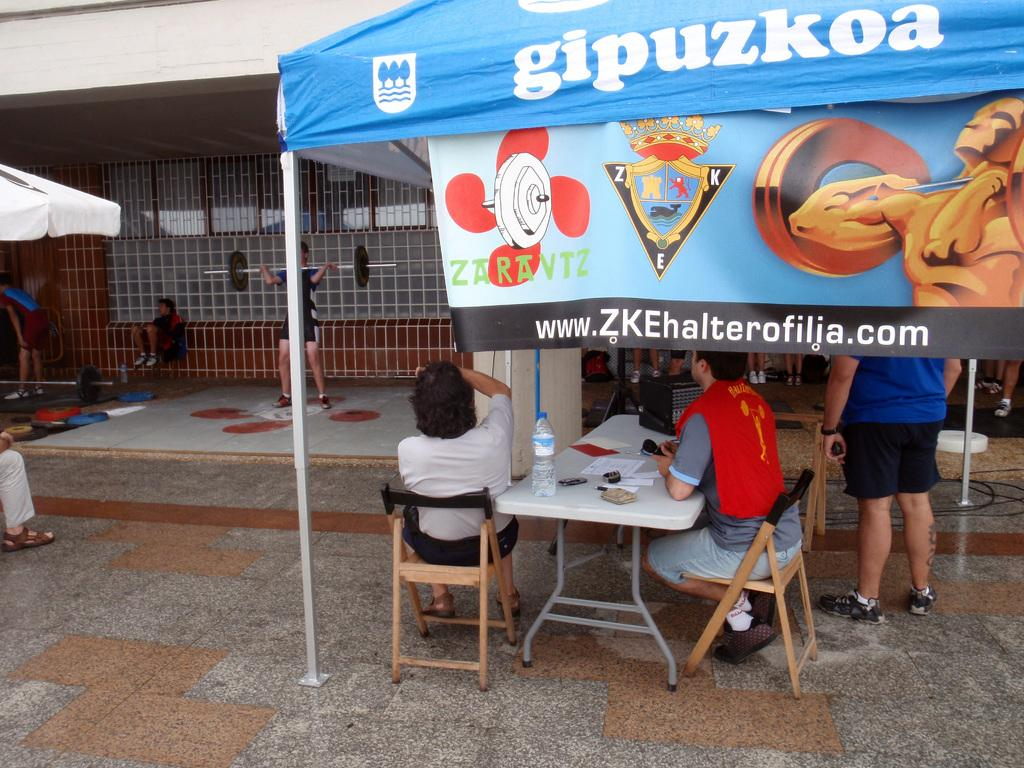What are the people doing under the tent in the image? The people are sitting and standing under a tent in the image. What can be seen on the table in the image? There is a water bottle and papers on the table in the image. What is the level of wealth displayed by the people in the image? The level of wealth cannot be determined from the image, as there is no information about the people's financial status. 